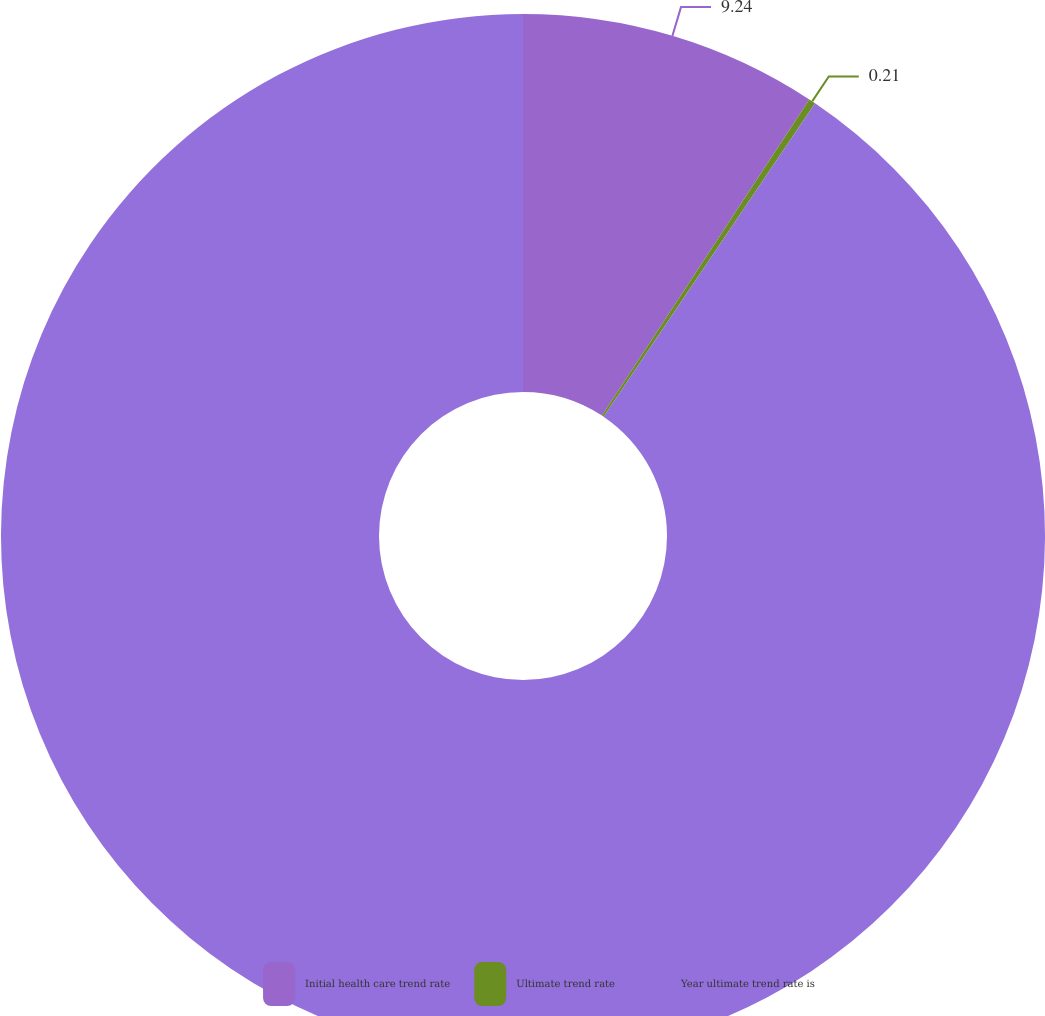<chart> <loc_0><loc_0><loc_500><loc_500><pie_chart><fcel>Initial health care trend rate<fcel>Ultimate trend rate<fcel>Year ultimate trend rate is<nl><fcel>9.24%<fcel>0.21%<fcel>90.55%<nl></chart> 